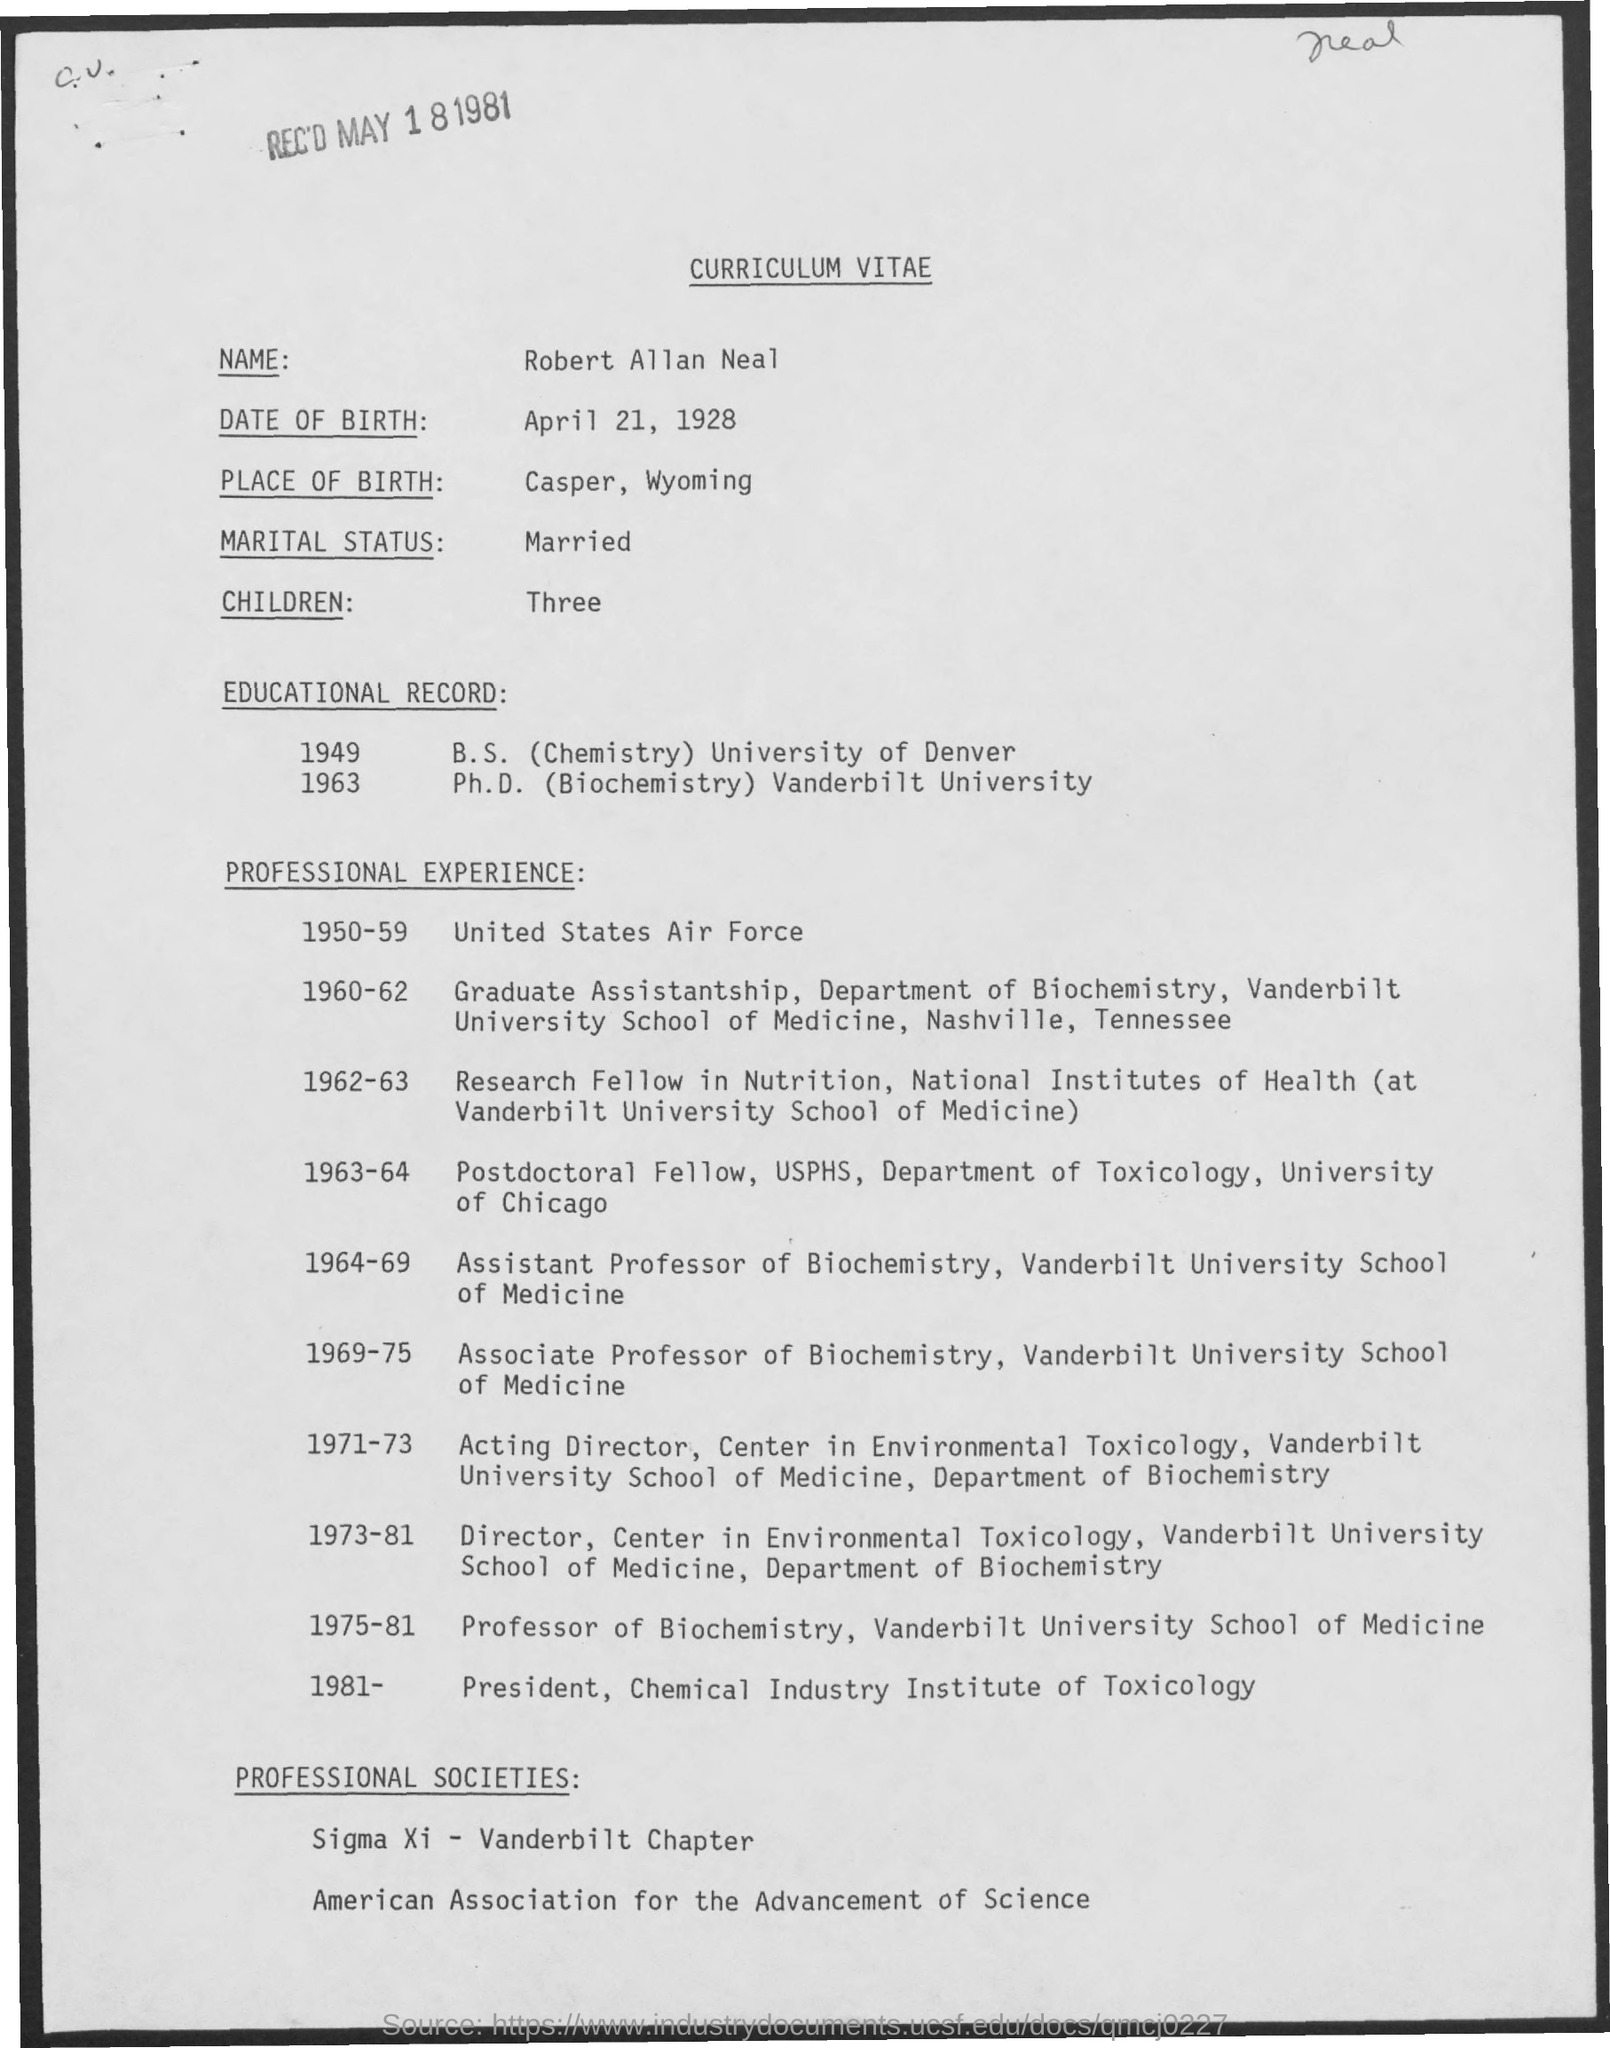What is the Title of the document?
Provide a succinct answer. Curriculum Vitae. What is the Name?
Ensure brevity in your answer.  Robert Allan Neal. What is the Date of Birth?
Keep it short and to the point. April 21, 1928. What is the place of Birth?
Your answer should be very brief. Casper, wyoming. What is the Marital status?
Offer a very short reply. Married. How many children?
Your answer should be compact. Three. 